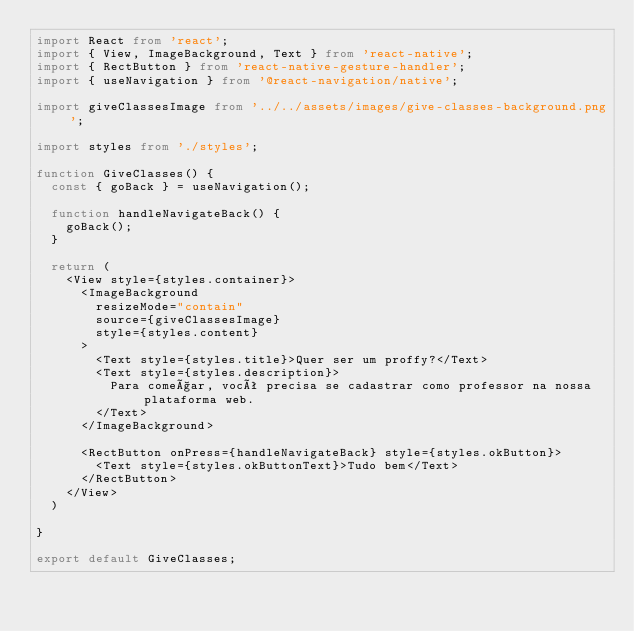<code> <loc_0><loc_0><loc_500><loc_500><_TypeScript_>import React from 'react';
import { View, ImageBackground, Text } from 'react-native';
import { RectButton } from 'react-native-gesture-handler';
import { useNavigation } from '@react-navigation/native';

import giveClassesImage from '../../assets/images/give-classes-background.png';

import styles from './styles';

function GiveClasses() {
  const { goBack } = useNavigation();

  function handleNavigateBack() {
    goBack();
  }

  return (
    <View style={styles.container}>
      <ImageBackground 
        resizeMode="contain" 
        source={giveClassesImage} 
        style={styles.content}
      >
        <Text style={styles.title}>Quer ser um proffy?</Text>
        <Text style={styles.description}>
          Para começar, você precisa se cadastrar como professor na nossa plataforma web.
        </Text>
      </ImageBackground>

      <RectButton onPress={handleNavigateBack} style={styles.okButton}>
        <Text style={styles.okButtonText}>Tudo bem</Text>
      </RectButton>
    </View>
  )
  
}

export default GiveClasses;</code> 